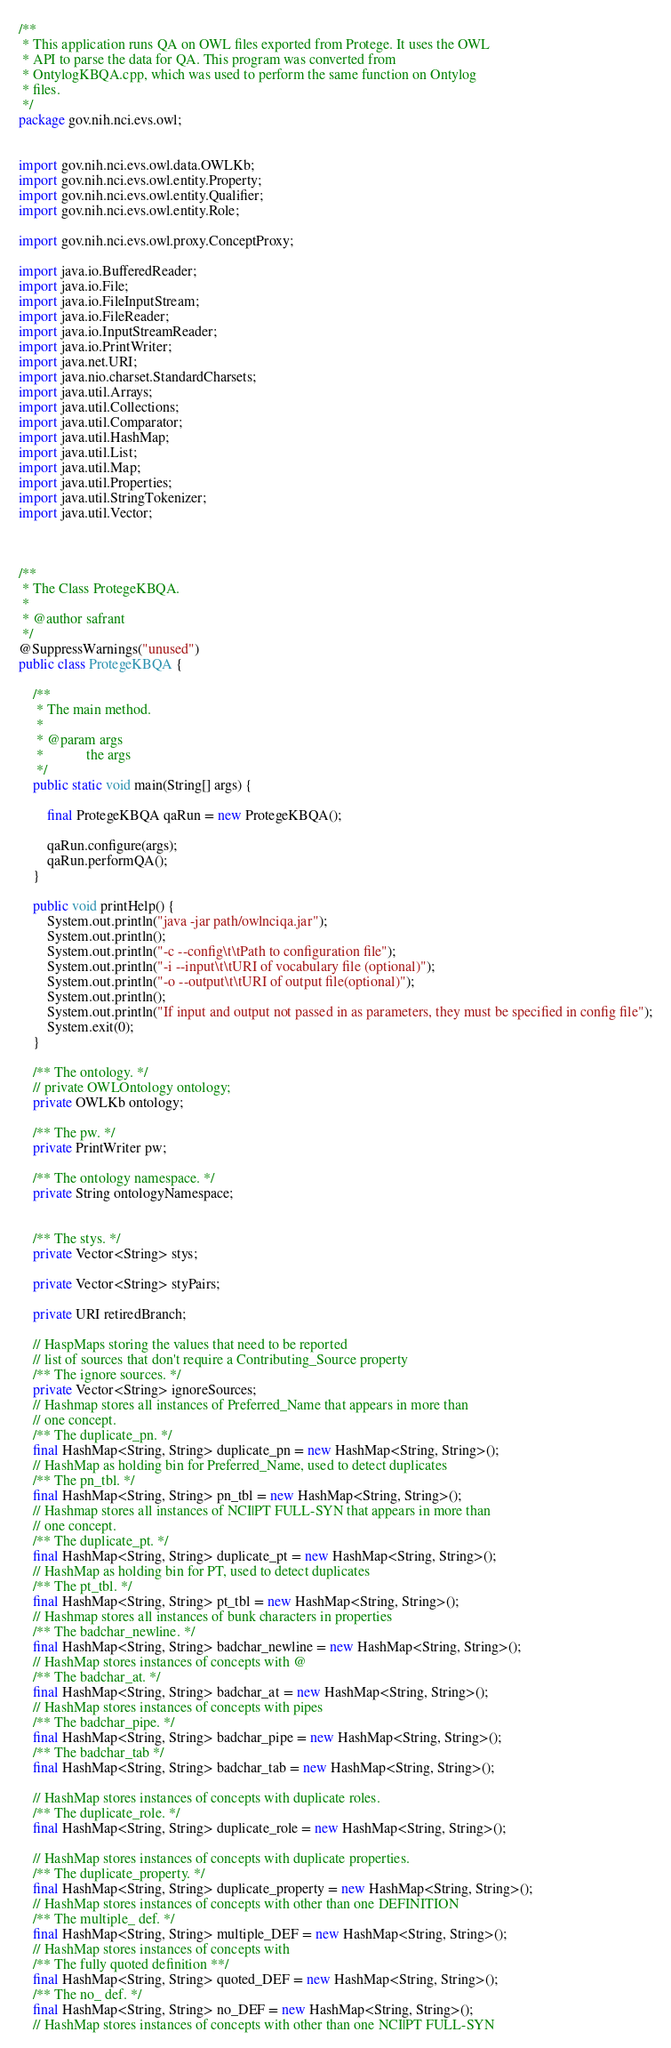<code> <loc_0><loc_0><loc_500><loc_500><_Java_>/**
 * This application runs QA on OWL files exported from Protege. It uses the OWL
 * API to parse the data for QA. This program was converted from
 * OntylogKBQA.cpp, which was used to perform the same function on Ontylog
 * files.
 */
package gov.nih.nci.evs.owl;


import gov.nih.nci.evs.owl.data.OWLKb;
import gov.nih.nci.evs.owl.entity.Property;
import gov.nih.nci.evs.owl.entity.Qualifier;
import gov.nih.nci.evs.owl.entity.Role;

import gov.nih.nci.evs.owl.proxy.ConceptProxy;

import java.io.BufferedReader;
import java.io.File;
import java.io.FileInputStream;
import java.io.FileReader;
import java.io.InputStreamReader;
import java.io.PrintWriter;
import java.net.URI;
import java.nio.charset.StandardCharsets;
import java.util.Arrays;
import java.util.Collections;
import java.util.Comparator;
import java.util.HashMap;
import java.util.List;
import java.util.Map;
import java.util.Properties;
import java.util.StringTokenizer;
import java.util.Vector;



/**
 * The Class ProtegeKBQA.
 * 
 * @author safrant
 */
@SuppressWarnings("unused")
public class ProtegeKBQA {

	/**
	 * The main method.
	 * 
	 * @param args
	 *            the args
	 */
	public static void main(String[] args) {

		final ProtegeKBQA qaRun = new ProtegeKBQA();

		qaRun.configure(args);
		qaRun.performQA();
	}

	public void printHelp() {
		System.out.println("java -jar path/owlnciqa.jar");
		System.out.println();
		System.out.println("-c --config\t\tPath to configuration file");
		System.out.println("-i --input\t\tURI of vocabulary file (optional)");
		System.out.println("-o --output\t\tURI of output file(optional)");
		System.out.println();
		System.out.println("If input and output not passed in as parameters, they must be specified in config file");
		System.exit(0);
	}

	/** The ontology. */
	// private OWLOntology ontology;
	private OWLKb ontology;

	/** The pw. */
	private PrintWriter pw;

	/** The ontology namespace. */
	private String ontologyNamespace;


	/** The stys. */
	private Vector<String> stys;

	private Vector<String> styPairs;

	private URI retiredBranch;

	// HaspMaps storing the values that need to be reported
	// list of sources that don't require a Contributing_Source property
	/** The ignore sources. */
	private Vector<String> ignoreSources;
	// Hashmap stores all instances of Preferred_Name that appears in more than
	// one concept.
	/** The duplicate_pn. */
	final HashMap<String, String> duplicate_pn = new HashMap<String, String>();
	// HashMap as holding bin for Preferred_Name, used to detect duplicates
	/** The pn_tbl. */
	final HashMap<String, String> pn_tbl = new HashMap<String, String>();
	// Hashmap stores all instances of NCI|PT FULL-SYN that appears in more than
	// one concept.
	/** The duplicate_pt. */
	final HashMap<String, String> duplicate_pt = new HashMap<String, String>();
	// HashMap as holding bin for PT, used to detect duplicates
	/** The pt_tbl. */
	final HashMap<String, String> pt_tbl = new HashMap<String, String>();
	// Hashmap stores all instances of bunk characters in properties
	/** The badchar_newline. */
	final HashMap<String, String> badchar_newline = new HashMap<String, String>();
	// HashMap stores instances of concepts with @
	/** The badchar_at. */
	final HashMap<String, String> badchar_at = new HashMap<String, String>();
	// HashMap stores instances of concepts with pipes
	/** The badchar_pipe. */
	final HashMap<String, String> badchar_pipe = new HashMap<String, String>();
	/** The badchar_tab */
	final HashMap<String, String> badchar_tab = new HashMap<String, String>();

	// HashMap stores instances of concepts with duplicate roles.
	/** The duplicate_role. */
	final HashMap<String, String> duplicate_role = new HashMap<String, String>();

	// HashMap stores instances of concepts with duplicate properties.
	/** The duplicate_property. */
	final HashMap<String, String> duplicate_property = new HashMap<String, String>();
	// HashMap stores instances of concepts with other than one DEFINITION
	/** The multiple_ def. */
	final HashMap<String, String> multiple_DEF = new HashMap<String, String>();
	// HashMap stores instances of concepts with
	/** The fully quoted definition **/
	final HashMap<String, String> quoted_DEF = new HashMap<String, String>();
	/** The no_ def. */
	final HashMap<String, String> no_DEF = new HashMap<String, String>();
	// HashMap stores instances of concepts with other than one NCI|PT FULL-SYN</code> 